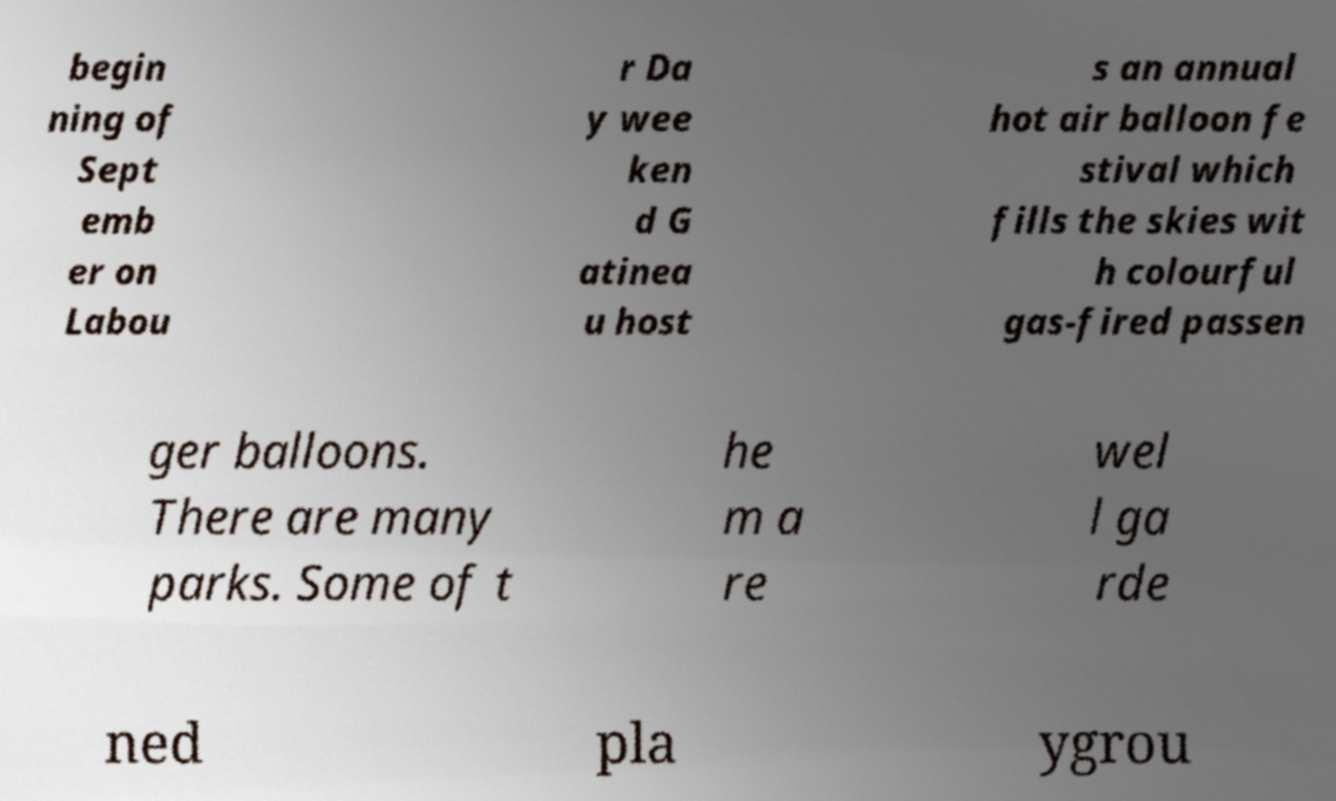Could you extract and type out the text from this image? begin ning of Sept emb er on Labou r Da y wee ken d G atinea u host s an annual hot air balloon fe stival which fills the skies wit h colourful gas-fired passen ger balloons. There are many parks. Some of t he m a re wel l ga rde ned pla ygrou 